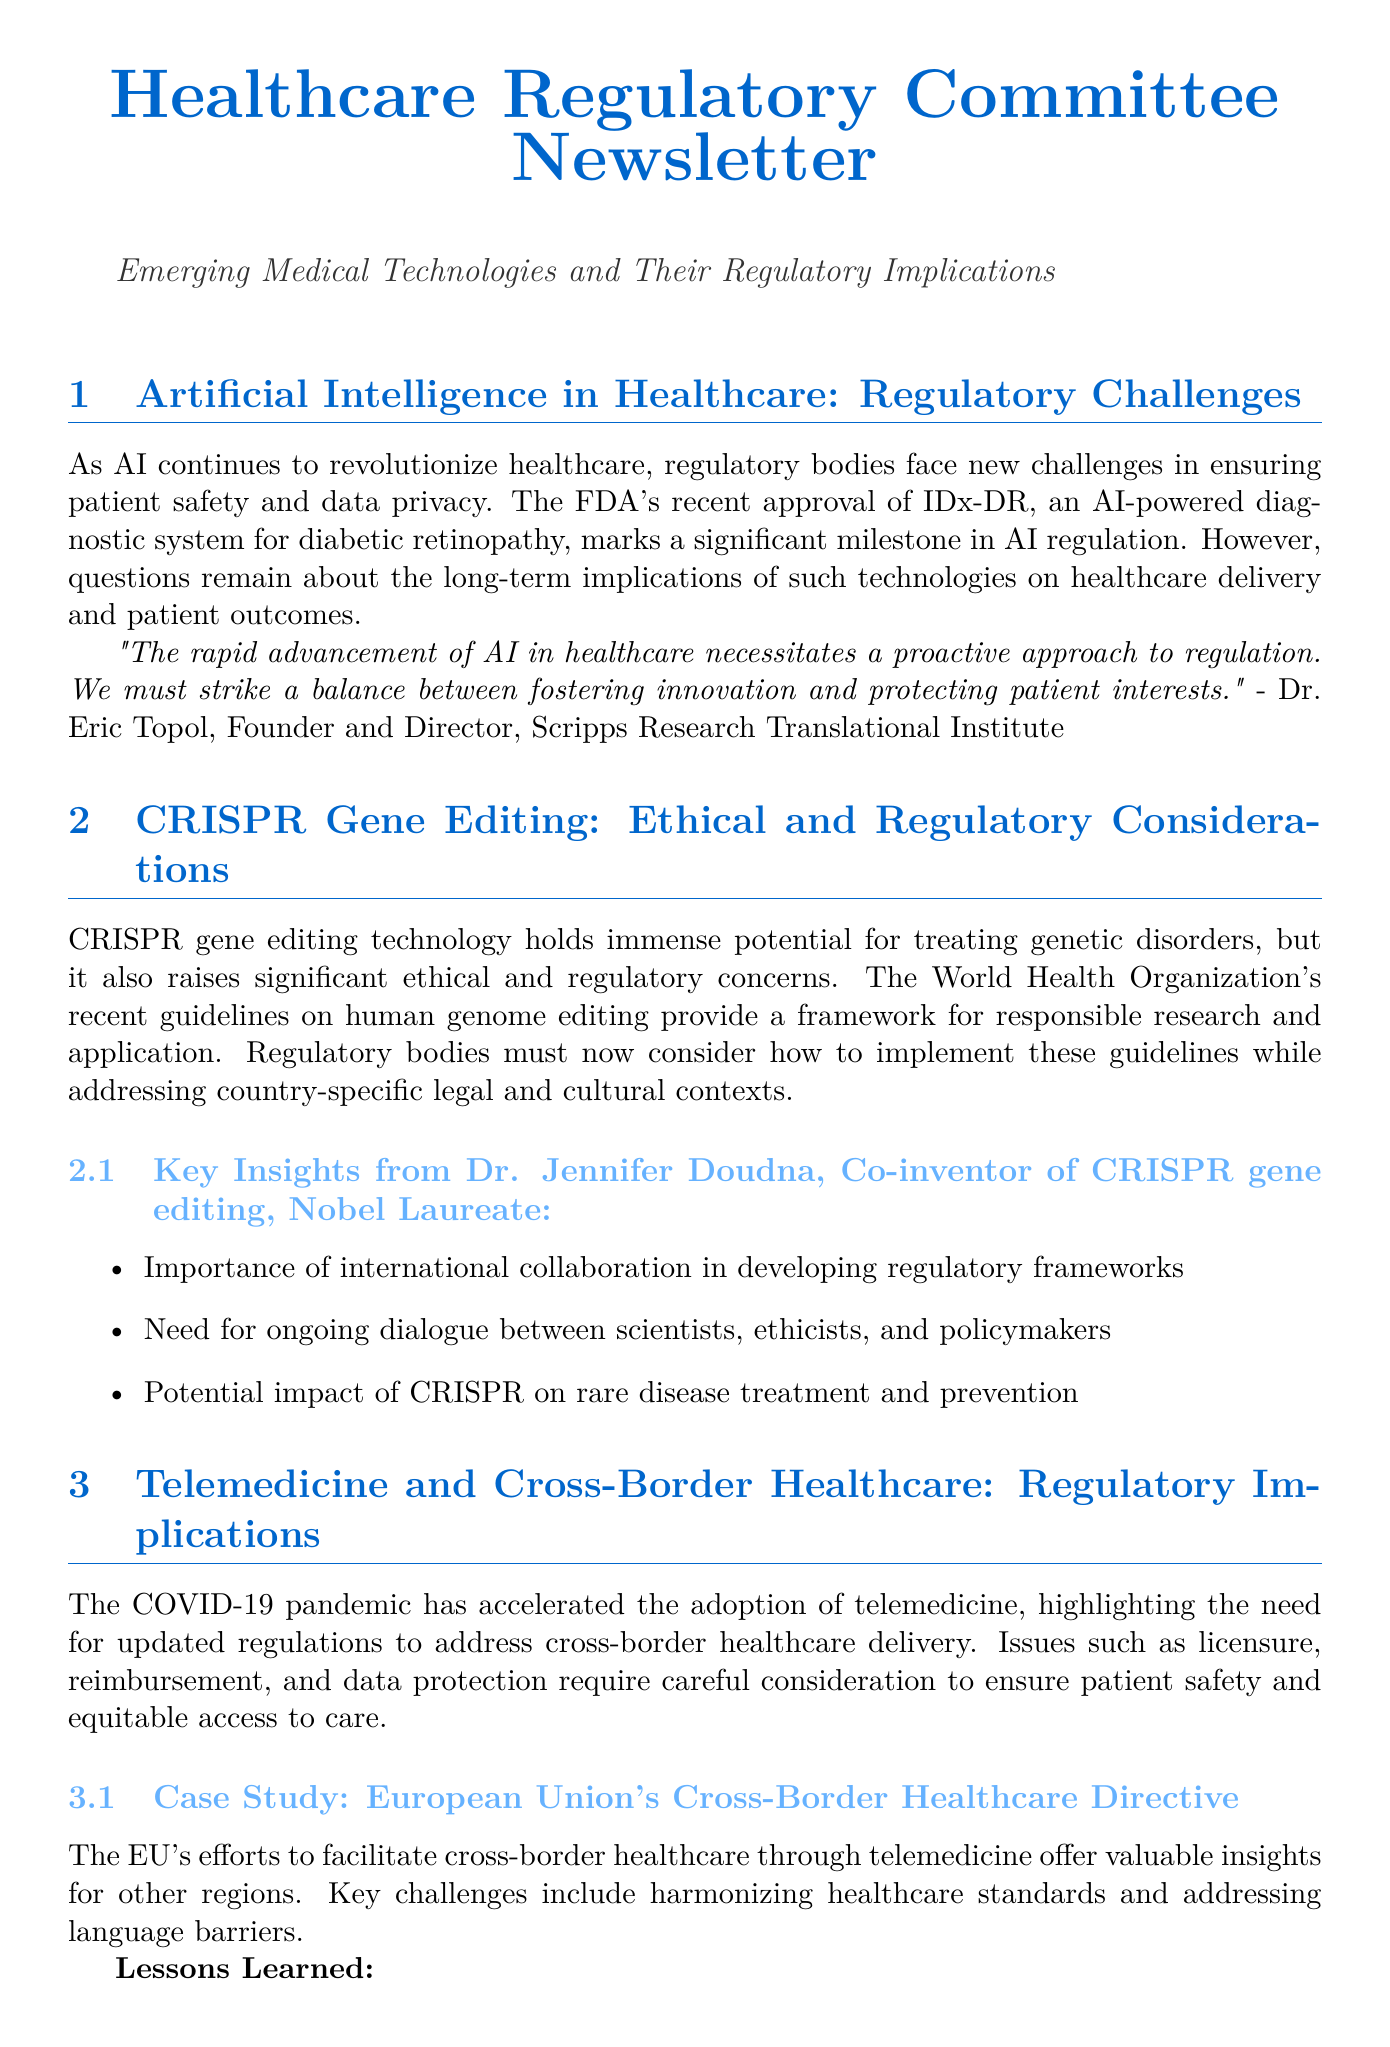What is the title of the newsletter? The title of the newsletter is highlighted at the beginning of the document.
Answer: Healthcare Regulatory Committee Newsletter Who is the founder and director of the Scripps Research Translational Institute? This person's name is mentioned along with their position in a quoted statement.
Answer: Dr. Eric Topol What technology does CRISPR gene editing aim to treat? The document specifically mentions the type of disorders CRISPR aims to address.
Answer: Genetic disorders What significant event did the COVID-19 pandemic influence in healthcare? The document discusses how the pandemic affected a specific service in healthcare.
Answer: Telemedicine adoption Which company is featured in the industry perspective section? The document lists this company under the blockchain discussion.
Answer: IBM Watson Health What are the key challenges faced by the EU's cross-border healthcare directive? The document summarizes these challenges under a specific case study.
Answer: Harmonizing healthcare standards and addressing language barriers What framework does the World Health Organization provide related to CRISPR? The document names the type of guidelines that the WHO recently released.
Answer: Guidelines on human genome editing Name one recommended action for regulatory decision-making. Several actions are listed in a dedicated section of the document.
Answer: Establish multidisciplinary advisory committees 